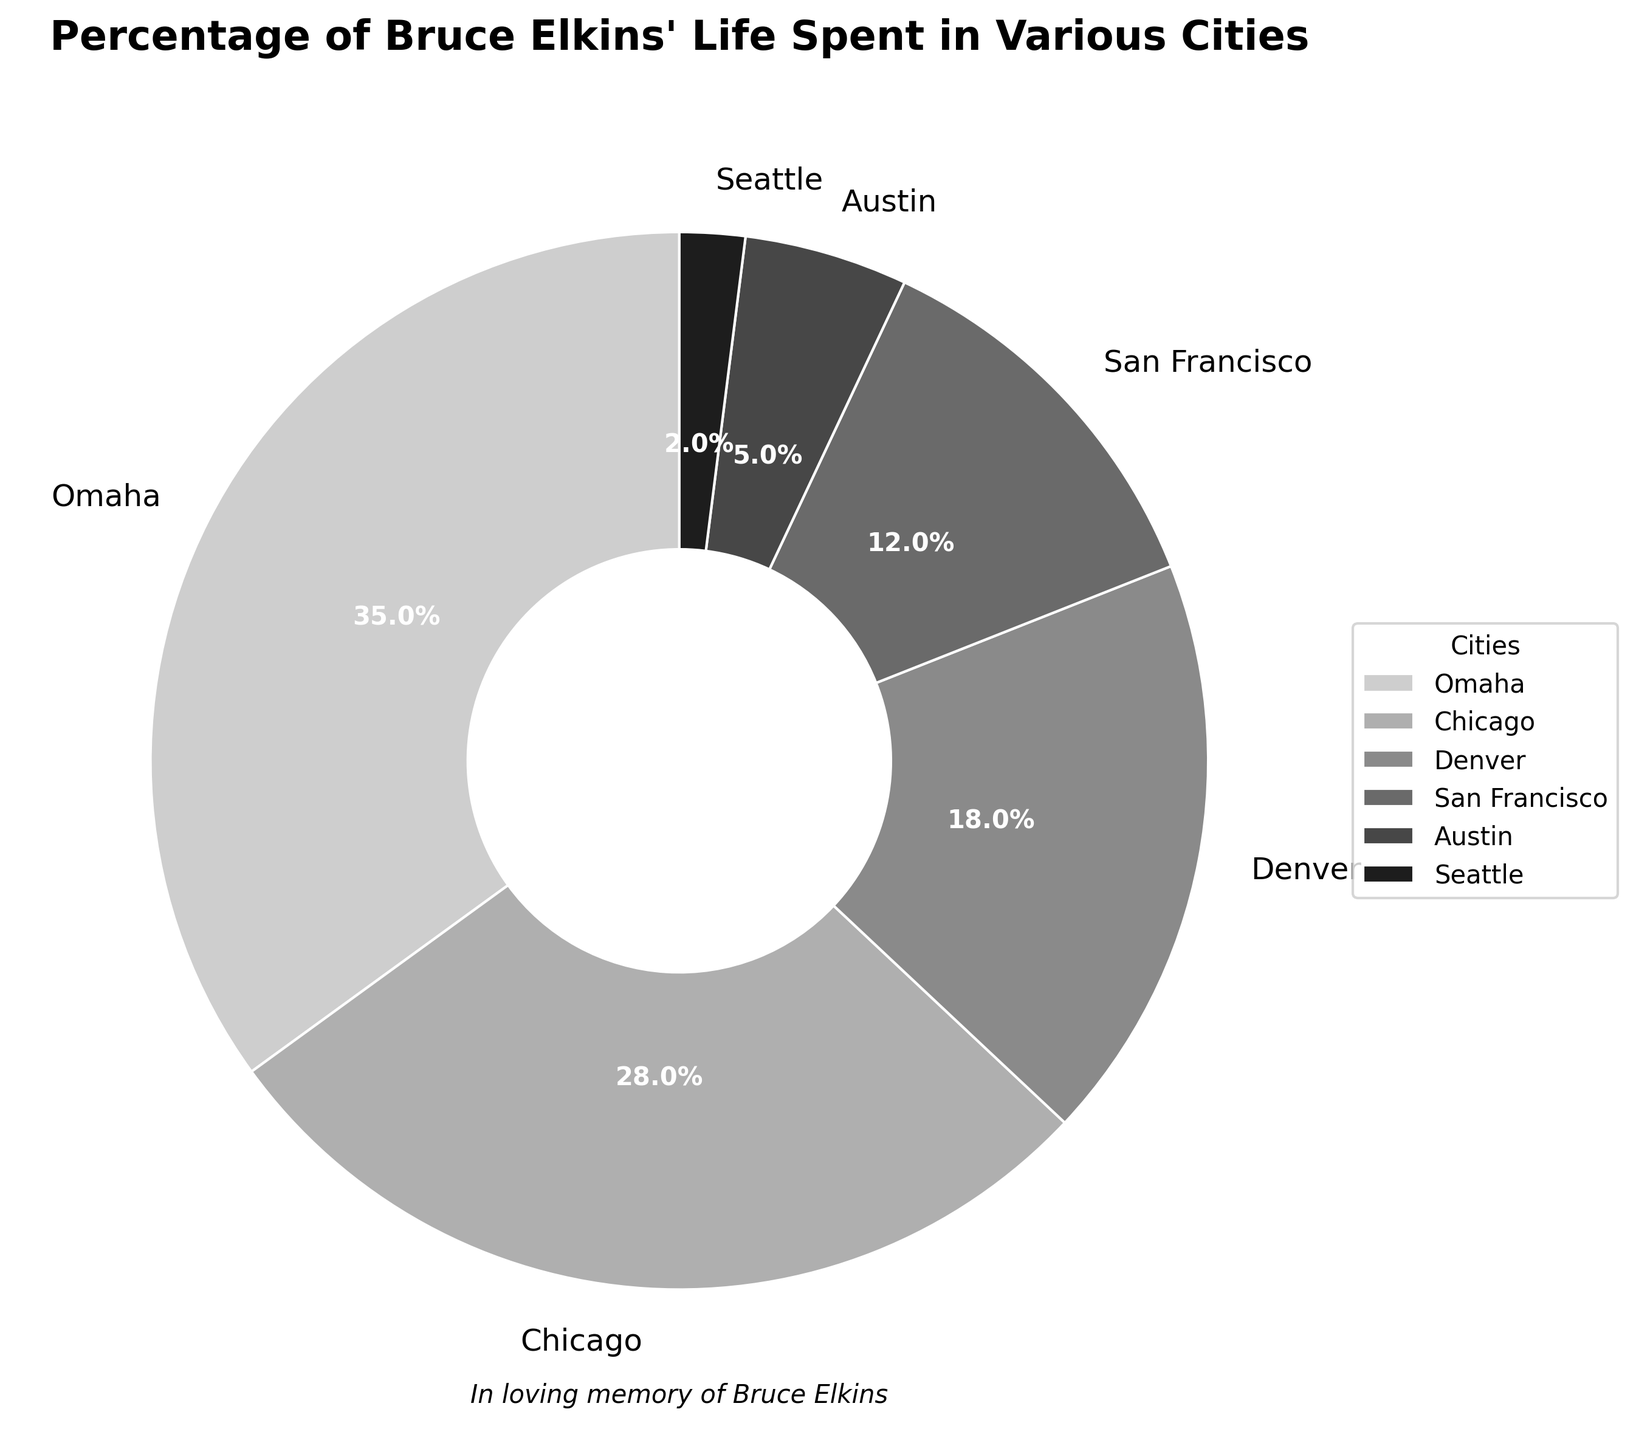What percentage of Bruce's life was spent in Omaha and Chicago combined? Add 35% (Omaha) and 28% (Chicago) to get the total percentage spent in both cities. 35 + 28 = 63
Answer: 63% Which city did Bruce spend the smallest percentage of his life in? Identify the city with the smallest slice, labeled with 2%.
Answer: Seattle How many cities did Bruce spend more than 10% of his life in? Count the cities where the percentage labels are greater than 10%. These cities are Omaha (35%), Chicago (28%), Denver (18%), and San Francisco (12%). In total, 4 cities.
Answer: 4 What is the difference in the percentage of life spent in San Francisco and Austin? Subtract the smaller percentage (Austin, 5%) from the larger percentage (San Francisco, 12%). 12 - 5 = 7
Answer: 7% What is the visual style used in the plot? The plot uses a grayscale style as indicated by the shades of grey in the pie chart and the general absence of color.
Answer: Grayscale Which city did Bruce spend the most time in? Identify the city with the largest slice, labeled with 35%.
Answer: Omaha How much more time did Bruce spend in Denver compared to Seattle? Subtract the smaller percentage (Seattle, 2%) from the larger percentage (Denver, 18%). 18 - 2 = 16
Answer: 16% What percentage of Bruce’s life was spent in cities other than Omaha and Chicago? Subtract the sum of the percentages for Omaha (35%) and Chicago (28%) from 100%. 100 - (35 + 28) = 37
Answer: 37% Which two cities had the closest percentages of Bruce’s life spent? Compare the percentages to find the two closest values. The closest percentages are San Francisco (12%) and Austin (5%), the difference being 7%.
Answer: San Francisco and Austin What does the text below the pie chart say? The text below the pie chart reads "In loving memory of Bruce Elkins".
Answer: In loving memory of Bruce Elkins 